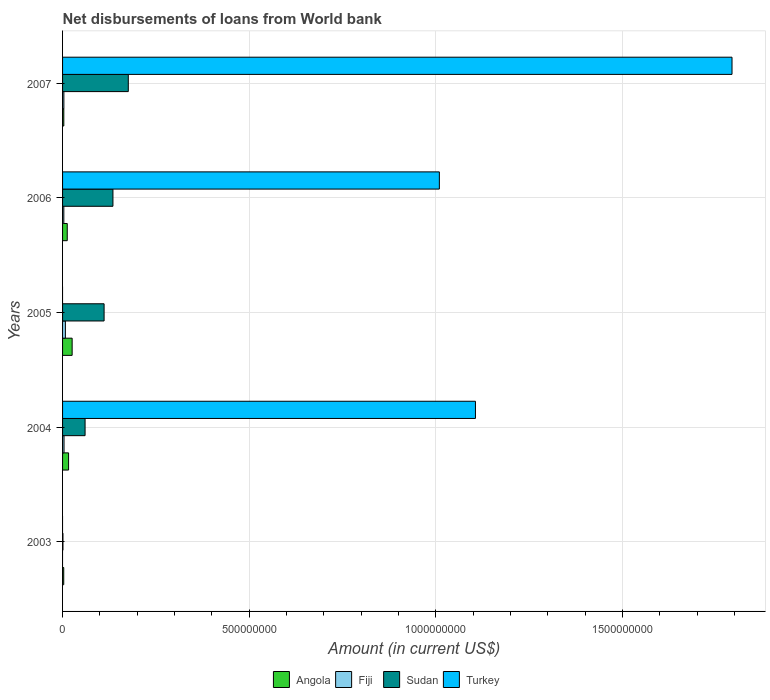How many different coloured bars are there?
Your response must be concise. 4. How many groups of bars are there?
Offer a terse response. 5. Are the number of bars per tick equal to the number of legend labels?
Make the answer very short. No. Are the number of bars on each tick of the Y-axis equal?
Your response must be concise. No. How many bars are there on the 3rd tick from the top?
Ensure brevity in your answer.  3. What is the label of the 2nd group of bars from the top?
Your answer should be very brief. 2006. What is the amount of loan disbursed from World Bank in Sudan in 2004?
Keep it short and to the point. 6.03e+07. Across all years, what is the maximum amount of loan disbursed from World Bank in Turkey?
Give a very brief answer. 1.79e+09. Across all years, what is the minimum amount of loan disbursed from World Bank in Fiji?
Give a very brief answer. 0. In which year was the amount of loan disbursed from World Bank in Sudan maximum?
Offer a very short reply. 2007. What is the total amount of loan disbursed from World Bank in Angola in the graph?
Your response must be concise. 6.08e+07. What is the difference between the amount of loan disbursed from World Bank in Sudan in 2004 and that in 2005?
Offer a terse response. -5.09e+07. What is the difference between the amount of loan disbursed from World Bank in Angola in 2006 and the amount of loan disbursed from World Bank in Turkey in 2003?
Ensure brevity in your answer.  1.25e+07. What is the average amount of loan disbursed from World Bank in Sudan per year?
Your response must be concise. 9.67e+07. In the year 2004, what is the difference between the amount of loan disbursed from World Bank in Turkey and amount of loan disbursed from World Bank in Sudan?
Your answer should be very brief. 1.05e+09. What is the ratio of the amount of loan disbursed from World Bank in Angola in 2005 to that in 2006?
Offer a terse response. 2.05. Is the amount of loan disbursed from World Bank in Angola in 2005 less than that in 2007?
Give a very brief answer. No. What is the difference between the highest and the second highest amount of loan disbursed from World Bank in Fiji?
Ensure brevity in your answer.  3.62e+06. What is the difference between the highest and the lowest amount of loan disbursed from World Bank in Fiji?
Keep it short and to the point. 7.55e+06. In how many years, is the amount of loan disbursed from World Bank in Sudan greater than the average amount of loan disbursed from World Bank in Sudan taken over all years?
Provide a succinct answer. 3. Is it the case that in every year, the sum of the amount of loan disbursed from World Bank in Fiji and amount of loan disbursed from World Bank in Angola is greater than the sum of amount of loan disbursed from World Bank in Sudan and amount of loan disbursed from World Bank in Turkey?
Offer a very short reply. No. Is it the case that in every year, the sum of the amount of loan disbursed from World Bank in Fiji and amount of loan disbursed from World Bank in Turkey is greater than the amount of loan disbursed from World Bank in Sudan?
Make the answer very short. No. Are all the bars in the graph horizontal?
Provide a short and direct response. Yes. What is the difference between two consecutive major ticks on the X-axis?
Provide a short and direct response. 5.00e+08. Does the graph contain any zero values?
Make the answer very short. Yes. Does the graph contain grids?
Ensure brevity in your answer.  Yes. How many legend labels are there?
Ensure brevity in your answer.  4. What is the title of the graph?
Provide a succinct answer. Net disbursements of loans from World bank. Does "Low income" appear as one of the legend labels in the graph?
Offer a terse response. No. What is the Amount (in current US$) in Angola in 2003?
Your answer should be very brief. 3.14e+06. What is the Amount (in current US$) of Sudan in 2003?
Offer a very short reply. 1.03e+06. What is the Amount (in current US$) in Angola in 2004?
Provide a succinct answer. 1.61e+07. What is the Amount (in current US$) of Fiji in 2004?
Provide a short and direct response. 3.93e+06. What is the Amount (in current US$) of Sudan in 2004?
Your response must be concise. 6.03e+07. What is the Amount (in current US$) in Turkey in 2004?
Give a very brief answer. 1.11e+09. What is the Amount (in current US$) of Angola in 2005?
Your answer should be compact. 2.57e+07. What is the Amount (in current US$) of Fiji in 2005?
Keep it short and to the point. 7.55e+06. What is the Amount (in current US$) of Sudan in 2005?
Offer a very short reply. 1.11e+08. What is the Amount (in current US$) in Angola in 2006?
Give a very brief answer. 1.25e+07. What is the Amount (in current US$) of Fiji in 2006?
Offer a very short reply. 3.38e+06. What is the Amount (in current US$) in Sudan in 2006?
Give a very brief answer. 1.35e+08. What is the Amount (in current US$) of Turkey in 2006?
Your answer should be very brief. 1.01e+09. What is the Amount (in current US$) of Angola in 2007?
Ensure brevity in your answer.  3.36e+06. What is the Amount (in current US$) of Fiji in 2007?
Provide a short and direct response. 3.51e+06. What is the Amount (in current US$) in Sudan in 2007?
Offer a terse response. 1.76e+08. What is the Amount (in current US$) of Turkey in 2007?
Give a very brief answer. 1.79e+09. Across all years, what is the maximum Amount (in current US$) of Angola?
Provide a short and direct response. 2.57e+07. Across all years, what is the maximum Amount (in current US$) in Fiji?
Your answer should be compact. 7.55e+06. Across all years, what is the maximum Amount (in current US$) in Sudan?
Keep it short and to the point. 1.76e+08. Across all years, what is the maximum Amount (in current US$) of Turkey?
Offer a very short reply. 1.79e+09. Across all years, what is the minimum Amount (in current US$) in Angola?
Give a very brief answer. 3.14e+06. Across all years, what is the minimum Amount (in current US$) in Fiji?
Your answer should be very brief. 0. Across all years, what is the minimum Amount (in current US$) in Sudan?
Make the answer very short. 1.03e+06. What is the total Amount (in current US$) of Angola in the graph?
Your answer should be compact. 6.08e+07. What is the total Amount (in current US$) in Fiji in the graph?
Your answer should be very brief. 1.84e+07. What is the total Amount (in current US$) in Sudan in the graph?
Offer a very short reply. 4.84e+08. What is the total Amount (in current US$) of Turkey in the graph?
Provide a succinct answer. 3.91e+09. What is the difference between the Amount (in current US$) in Angola in 2003 and that in 2004?
Your answer should be very brief. -1.30e+07. What is the difference between the Amount (in current US$) of Sudan in 2003 and that in 2004?
Provide a succinct answer. -5.93e+07. What is the difference between the Amount (in current US$) in Angola in 2003 and that in 2005?
Offer a terse response. -2.25e+07. What is the difference between the Amount (in current US$) in Sudan in 2003 and that in 2005?
Keep it short and to the point. -1.10e+08. What is the difference between the Amount (in current US$) of Angola in 2003 and that in 2006?
Give a very brief answer. -9.39e+06. What is the difference between the Amount (in current US$) in Sudan in 2003 and that in 2006?
Make the answer very short. -1.34e+08. What is the difference between the Amount (in current US$) in Angola in 2003 and that in 2007?
Your answer should be compact. -2.14e+05. What is the difference between the Amount (in current US$) in Sudan in 2003 and that in 2007?
Keep it short and to the point. -1.75e+08. What is the difference between the Amount (in current US$) in Angola in 2004 and that in 2005?
Keep it short and to the point. -9.56e+06. What is the difference between the Amount (in current US$) in Fiji in 2004 and that in 2005?
Your response must be concise. -3.62e+06. What is the difference between the Amount (in current US$) in Sudan in 2004 and that in 2005?
Give a very brief answer. -5.09e+07. What is the difference between the Amount (in current US$) in Angola in 2004 and that in 2006?
Offer a terse response. 3.57e+06. What is the difference between the Amount (in current US$) in Fiji in 2004 and that in 2006?
Offer a very short reply. 5.57e+05. What is the difference between the Amount (in current US$) in Sudan in 2004 and that in 2006?
Your answer should be compact. -7.46e+07. What is the difference between the Amount (in current US$) in Turkey in 2004 and that in 2006?
Ensure brevity in your answer.  9.67e+07. What is the difference between the Amount (in current US$) in Angola in 2004 and that in 2007?
Your response must be concise. 1.28e+07. What is the difference between the Amount (in current US$) of Fiji in 2004 and that in 2007?
Provide a short and direct response. 4.22e+05. What is the difference between the Amount (in current US$) in Sudan in 2004 and that in 2007?
Keep it short and to the point. -1.16e+08. What is the difference between the Amount (in current US$) of Turkey in 2004 and that in 2007?
Offer a terse response. -6.87e+08. What is the difference between the Amount (in current US$) in Angola in 2005 and that in 2006?
Ensure brevity in your answer.  1.31e+07. What is the difference between the Amount (in current US$) of Fiji in 2005 and that in 2006?
Give a very brief answer. 4.18e+06. What is the difference between the Amount (in current US$) of Sudan in 2005 and that in 2006?
Give a very brief answer. -2.37e+07. What is the difference between the Amount (in current US$) of Angola in 2005 and that in 2007?
Keep it short and to the point. 2.23e+07. What is the difference between the Amount (in current US$) in Fiji in 2005 and that in 2007?
Keep it short and to the point. 4.04e+06. What is the difference between the Amount (in current US$) in Sudan in 2005 and that in 2007?
Ensure brevity in your answer.  -6.48e+07. What is the difference between the Amount (in current US$) in Angola in 2006 and that in 2007?
Your answer should be compact. 9.18e+06. What is the difference between the Amount (in current US$) of Fiji in 2006 and that in 2007?
Ensure brevity in your answer.  -1.35e+05. What is the difference between the Amount (in current US$) of Sudan in 2006 and that in 2007?
Provide a succinct answer. -4.11e+07. What is the difference between the Amount (in current US$) of Turkey in 2006 and that in 2007?
Make the answer very short. -7.84e+08. What is the difference between the Amount (in current US$) of Angola in 2003 and the Amount (in current US$) of Fiji in 2004?
Make the answer very short. -7.89e+05. What is the difference between the Amount (in current US$) of Angola in 2003 and the Amount (in current US$) of Sudan in 2004?
Give a very brief answer. -5.72e+07. What is the difference between the Amount (in current US$) in Angola in 2003 and the Amount (in current US$) in Turkey in 2004?
Keep it short and to the point. -1.10e+09. What is the difference between the Amount (in current US$) in Sudan in 2003 and the Amount (in current US$) in Turkey in 2004?
Your answer should be compact. -1.10e+09. What is the difference between the Amount (in current US$) of Angola in 2003 and the Amount (in current US$) of Fiji in 2005?
Ensure brevity in your answer.  -4.41e+06. What is the difference between the Amount (in current US$) in Angola in 2003 and the Amount (in current US$) in Sudan in 2005?
Provide a succinct answer. -1.08e+08. What is the difference between the Amount (in current US$) in Angola in 2003 and the Amount (in current US$) in Fiji in 2006?
Your answer should be compact. -2.32e+05. What is the difference between the Amount (in current US$) in Angola in 2003 and the Amount (in current US$) in Sudan in 2006?
Offer a very short reply. -1.32e+08. What is the difference between the Amount (in current US$) in Angola in 2003 and the Amount (in current US$) in Turkey in 2006?
Your answer should be very brief. -1.01e+09. What is the difference between the Amount (in current US$) in Sudan in 2003 and the Amount (in current US$) in Turkey in 2006?
Give a very brief answer. -1.01e+09. What is the difference between the Amount (in current US$) of Angola in 2003 and the Amount (in current US$) of Fiji in 2007?
Your answer should be compact. -3.67e+05. What is the difference between the Amount (in current US$) of Angola in 2003 and the Amount (in current US$) of Sudan in 2007?
Provide a succinct answer. -1.73e+08. What is the difference between the Amount (in current US$) of Angola in 2003 and the Amount (in current US$) of Turkey in 2007?
Your response must be concise. -1.79e+09. What is the difference between the Amount (in current US$) in Sudan in 2003 and the Amount (in current US$) in Turkey in 2007?
Provide a short and direct response. -1.79e+09. What is the difference between the Amount (in current US$) of Angola in 2004 and the Amount (in current US$) of Fiji in 2005?
Offer a terse response. 8.56e+06. What is the difference between the Amount (in current US$) of Angola in 2004 and the Amount (in current US$) of Sudan in 2005?
Give a very brief answer. -9.51e+07. What is the difference between the Amount (in current US$) of Fiji in 2004 and the Amount (in current US$) of Sudan in 2005?
Make the answer very short. -1.07e+08. What is the difference between the Amount (in current US$) of Angola in 2004 and the Amount (in current US$) of Fiji in 2006?
Provide a short and direct response. 1.27e+07. What is the difference between the Amount (in current US$) of Angola in 2004 and the Amount (in current US$) of Sudan in 2006?
Provide a succinct answer. -1.19e+08. What is the difference between the Amount (in current US$) of Angola in 2004 and the Amount (in current US$) of Turkey in 2006?
Your answer should be very brief. -9.93e+08. What is the difference between the Amount (in current US$) of Fiji in 2004 and the Amount (in current US$) of Sudan in 2006?
Provide a succinct answer. -1.31e+08. What is the difference between the Amount (in current US$) of Fiji in 2004 and the Amount (in current US$) of Turkey in 2006?
Ensure brevity in your answer.  -1.01e+09. What is the difference between the Amount (in current US$) of Sudan in 2004 and the Amount (in current US$) of Turkey in 2006?
Keep it short and to the point. -9.49e+08. What is the difference between the Amount (in current US$) of Angola in 2004 and the Amount (in current US$) of Fiji in 2007?
Offer a very short reply. 1.26e+07. What is the difference between the Amount (in current US$) of Angola in 2004 and the Amount (in current US$) of Sudan in 2007?
Offer a terse response. -1.60e+08. What is the difference between the Amount (in current US$) in Angola in 2004 and the Amount (in current US$) in Turkey in 2007?
Ensure brevity in your answer.  -1.78e+09. What is the difference between the Amount (in current US$) in Fiji in 2004 and the Amount (in current US$) in Sudan in 2007?
Make the answer very short. -1.72e+08. What is the difference between the Amount (in current US$) of Fiji in 2004 and the Amount (in current US$) of Turkey in 2007?
Your answer should be compact. -1.79e+09. What is the difference between the Amount (in current US$) of Sudan in 2004 and the Amount (in current US$) of Turkey in 2007?
Provide a short and direct response. -1.73e+09. What is the difference between the Amount (in current US$) in Angola in 2005 and the Amount (in current US$) in Fiji in 2006?
Provide a succinct answer. 2.23e+07. What is the difference between the Amount (in current US$) of Angola in 2005 and the Amount (in current US$) of Sudan in 2006?
Provide a short and direct response. -1.09e+08. What is the difference between the Amount (in current US$) in Angola in 2005 and the Amount (in current US$) in Turkey in 2006?
Give a very brief answer. -9.84e+08. What is the difference between the Amount (in current US$) of Fiji in 2005 and the Amount (in current US$) of Sudan in 2006?
Provide a short and direct response. -1.27e+08. What is the difference between the Amount (in current US$) of Fiji in 2005 and the Amount (in current US$) of Turkey in 2006?
Your response must be concise. -1.00e+09. What is the difference between the Amount (in current US$) in Sudan in 2005 and the Amount (in current US$) in Turkey in 2006?
Provide a short and direct response. -8.98e+08. What is the difference between the Amount (in current US$) in Angola in 2005 and the Amount (in current US$) in Fiji in 2007?
Offer a very short reply. 2.22e+07. What is the difference between the Amount (in current US$) in Angola in 2005 and the Amount (in current US$) in Sudan in 2007?
Make the answer very short. -1.50e+08. What is the difference between the Amount (in current US$) in Angola in 2005 and the Amount (in current US$) in Turkey in 2007?
Offer a terse response. -1.77e+09. What is the difference between the Amount (in current US$) in Fiji in 2005 and the Amount (in current US$) in Sudan in 2007?
Ensure brevity in your answer.  -1.69e+08. What is the difference between the Amount (in current US$) of Fiji in 2005 and the Amount (in current US$) of Turkey in 2007?
Make the answer very short. -1.79e+09. What is the difference between the Amount (in current US$) of Sudan in 2005 and the Amount (in current US$) of Turkey in 2007?
Provide a succinct answer. -1.68e+09. What is the difference between the Amount (in current US$) of Angola in 2006 and the Amount (in current US$) of Fiji in 2007?
Ensure brevity in your answer.  9.02e+06. What is the difference between the Amount (in current US$) in Angola in 2006 and the Amount (in current US$) in Sudan in 2007?
Give a very brief answer. -1.64e+08. What is the difference between the Amount (in current US$) of Angola in 2006 and the Amount (in current US$) of Turkey in 2007?
Provide a succinct answer. -1.78e+09. What is the difference between the Amount (in current US$) of Fiji in 2006 and the Amount (in current US$) of Sudan in 2007?
Your answer should be very brief. -1.73e+08. What is the difference between the Amount (in current US$) of Fiji in 2006 and the Amount (in current US$) of Turkey in 2007?
Keep it short and to the point. -1.79e+09. What is the difference between the Amount (in current US$) in Sudan in 2006 and the Amount (in current US$) in Turkey in 2007?
Provide a succinct answer. -1.66e+09. What is the average Amount (in current US$) of Angola per year?
Offer a terse response. 1.22e+07. What is the average Amount (in current US$) of Fiji per year?
Offer a very short reply. 3.68e+06. What is the average Amount (in current US$) in Sudan per year?
Make the answer very short. 9.67e+07. What is the average Amount (in current US$) in Turkey per year?
Provide a short and direct response. 7.82e+08. In the year 2003, what is the difference between the Amount (in current US$) of Angola and Amount (in current US$) of Sudan?
Provide a succinct answer. 2.11e+06. In the year 2004, what is the difference between the Amount (in current US$) in Angola and Amount (in current US$) in Fiji?
Your answer should be very brief. 1.22e+07. In the year 2004, what is the difference between the Amount (in current US$) of Angola and Amount (in current US$) of Sudan?
Provide a short and direct response. -4.42e+07. In the year 2004, what is the difference between the Amount (in current US$) of Angola and Amount (in current US$) of Turkey?
Provide a short and direct response. -1.09e+09. In the year 2004, what is the difference between the Amount (in current US$) of Fiji and Amount (in current US$) of Sudan?
Keep it short and to the point. -5.64e+07. In the year 2004, what is the difference between the Amount (in current US$) of Fiji and Amount (in current US$) of Turkey?
Offer a terse response. -1.10e+09. In the year 2004, what is the difference between the Amount (in current US$) in Sudan and Amount (in current US$) in Turkey?
Your answer should be very brief. -1.05e+09. In the year 2005, what is the difference between the Amount (in current US$) of Angola and Amount (in current US$) of Fiji?
Your answer should be very brief. 1.81e+07. In the year 2005, what is the difference between the Amount (in current US$) of Angola and Amount (in current US$) of Sudan?
Offer a very short reply. -8.56e+07. In the year 2005, what is the difference between the Amount (in current US$) of Fiji and Amount (in current US$) of Sudan?
Give a very brief answer. -1.04e+08. In the year 2006, what is the difference between the Amount (in current US$) of Angola and Amount (in current US$) of Fiji?
Make the answer very short. 9.16e+06. In the year 2006, what is the difference between the Amount (in current US$) in Angola and Amount (in current US$) in Sudan?
Your response must be concise. -1.22e+08. In the year 2006, what is the difference between the Amount (in current US$) of Angola and Amount (in current US$) of Turkey?
Your response must be concise. -9.97e+08. In the year 2006, what is the difference between the Amount (in current US$) of Fiji and Amount (in current US$) of Sudan?
Ensure brevity in your answer.  -1.32e+08. In the year 2006, what is the difference between the Amount (in current US$) of Fiji and Amount (in current US$) of Turkey?
Make the answer very short. -1.01e+09. In the year 2006, what is the difference between the Amount (in current US$) of Sudan and Amount (in current US$) of Turkey?
Your response must be concise. -8.74e+08. In the year 2007, what is the difference between the Amount (in current US$) in Angola and Amount (in current US$) in Fiji?
Offer a terse response. -1.53e+05. In the year 2007, what is the difference between the Amount (in current US$) of Angola and Amount (in current US$) of Sudan?
Your answer should be very brief. -1.73e+08. In the year 2007, what is the difference between the Amount (in current US$) of Angola and Amount (in current US$) of Turkey?
Your answer should be compact. -1.79e+09. In the year 2007, what is the difference between the Amount (in current US$) of Fiji and Amount (in current US$) of Sudan?
Your answer should be compact. -1.73e+08. In the year 2007, what is the difference between the Amount (in current US$) of Fiji and Amount (in current US$) of Turkey?
Provide a succinct answer. -1.79e+09. In the year 2007, what is the difference between the Amount (in current US$) in Sudan and Amount (in current US$) in Turkey?
Provide a succinct answer. -1.62e+09. What is the ratio of the Amount (in current US$) of Angola in 2003 to that in 2004?
Provide a succinct answer. 0.2. What is the ratio of the Amount (in current US$) in Sudan in 2003 to that in 2004?
Provide a succinct answer. 0.02. What is the ratio of the Amount (in current US$) of Angola in 2003 to that in 2005?
Offer a very short reply. 0.12. What is the ratio of the Amount (in current US$) of Sudan in 2003 to that in 2005?
Ensure brevity in your answer.  0.01. What is the ratio of the Amount (in current US$) of Angola in 2003 to that in 2006?
Ensure brevity in your answer.  0.25. What is the ratio of the Amount (in current US$) of Sudan in 2003 to that in 2006?
Keep it short and to the point. 0.01. What is the ratio of the Amount (in current US$) of Angola in 2003 to that in 2007?
Your answer should be very brief. 0.94. What is the ratio of the Amount (in current US$) in Sudan in 2003 to that in 2007?
Offer a very short reply. 0.01. What is the ratio of the Amount (in current US$) of Angola in 2004 to that in 2005?
Provide a short and direct response. 0.63. What is the ratio of the Amount (in current US$) of Fiji in 2004 to that in 2005?
Offer a terse response. 0.52. What is the ratio of the Amount (in current US$) in Sudan in 2004 to that in 2005?
Make the answer very short. 0.54. What is the ratio of the Amount (in current US$) of Angola in 2004 to that in 2006?
Give a very brief answer. 1.28. What is the ratio of the Amount (in current US$) of Fiji in 2004 to that in 2006?
Ensure brevity in your answer.  1.16. What is the ratio of the Amount (in current US$) of Sudan in 2004 to that in 2006?
Make the answer very short. 0.45. What is the ratio of the Amount (in current US$) of Turkey in 2004 to that in 2006?
Make the answer very short. 1.1. What is the ratio of the Amount (in current US$) in Angola in 2004 to that in 2007?
Your answer should be compact. 4.8. What is the ratio of the Amount (in current US$) of Fiji in 2004 to that in 2007?
Provide a succinct answer. 1.12. What is the ratio of the Amount (in current US$) in Sudan in 2004 to that in 2007?
Your response must be concise. 0.34. What is the ratio of the Amount (in current US$) in Turkey in 2004 to that in 2007?
Keep it short and to the point. 0.62. What is the ratio of the Amount (in current US$) in Angola in 2005 to that in 2006?
Offer a very short reply. 2.05. What is the ratio of the Amount (in current US$) in Fiji in 2005 to that in 2006?
Ensure brevity in your answer.  2.24. What is the ratio of the Amount (in current US$) in Sudan in 2005 to that in 2006?
Your response must be concise. 0.82. What is the ratio of the Amount (in current US$) in Angola in 2005 to that in 2007?
Your answer should be compact. 7.64. What is the ratio of the Amount (in current US$) of Fiji in 2005 to that in 2007?
Keep it short and to the point. 2.15. What is the ratio of the Amount (in current US$) of Sudan in 2005 to that in 2007?
Provide a succinct answer. 0.63. What is the ratio of the Amount (in current US$) of Angola in 2006 to that in 2007?
Provide a short and direct response. 3.73. What is the ratio of the Amount (in current US$) of Fiji in 2006 to that in 2007?
Provide a succinct answer. 0.96. What is the ratio of the Amount (in current US$) of Sudan in 2006 to that in 2007?
Offer a terse response. 0.77. What is the ratio of the Amount (in current US$) of Turkey in 2006 to that in 2007?
Your answer should be compact. 0.56. What is the difference between the highest and the second highest Amount (in current US$) in Angola?
Provide a succinct answer. 9.56e+06. What is the difference between the highest and the second highest Amount (in current US$) in Fiji?
Ensure brevity in your answer.  3.62e+06. What is the difference between the highest and the second highest Amount (in current US$) in Sudan?
Provide a short and direct response. 4.11e+07. What is the difference between the highest and the second highest Amount (in current US$) of Turkey?
Keep it short and to the point. 6.87e+08. What is the difference between the highest and the lowest Amount (in current US$) in Angola?
Provide a succinct answer. 2.25e+07. What is the difference between the highest and the lowest Amount (in current US$) in Fiji?
Offer a terse response. 7.55e+06. What is the difference between the highest and the lowest Amount (in current US$) of Sudan?
Ensure brevity in your answer.  1.75e+08. What is the difference between the highest and the lowest Amount (in current US$) in Turkey?
Your answer should be very brief. 1.79e+09. 